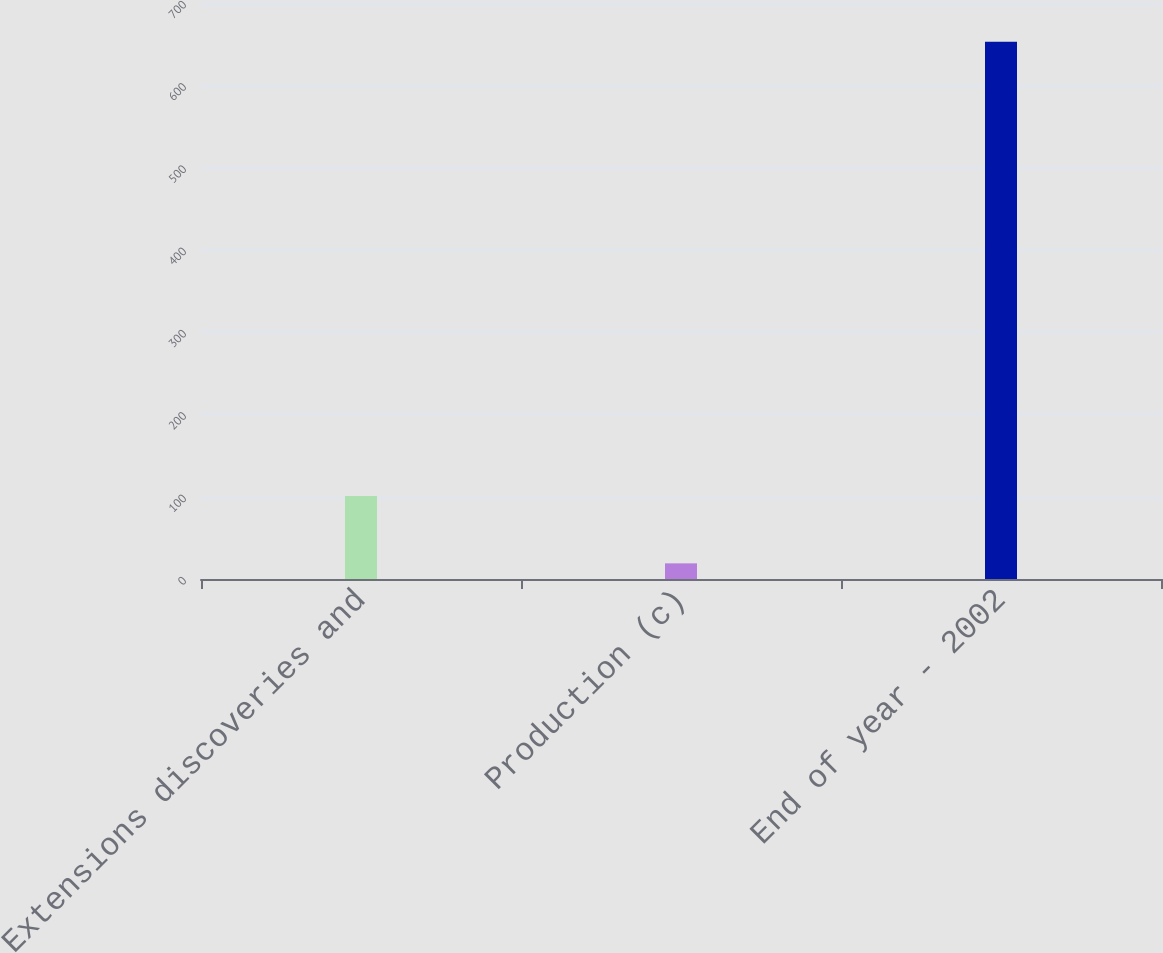Convert chart to OTSL. <chart><loc_0><loc_0><loc_500><loc_500><bar_chart><fcel>Extensions discoveries and<fcel>Production (c)<fcel>End of year - 2002<nl><fcel>101<fcel>19<fcel>653<nl></chart> 